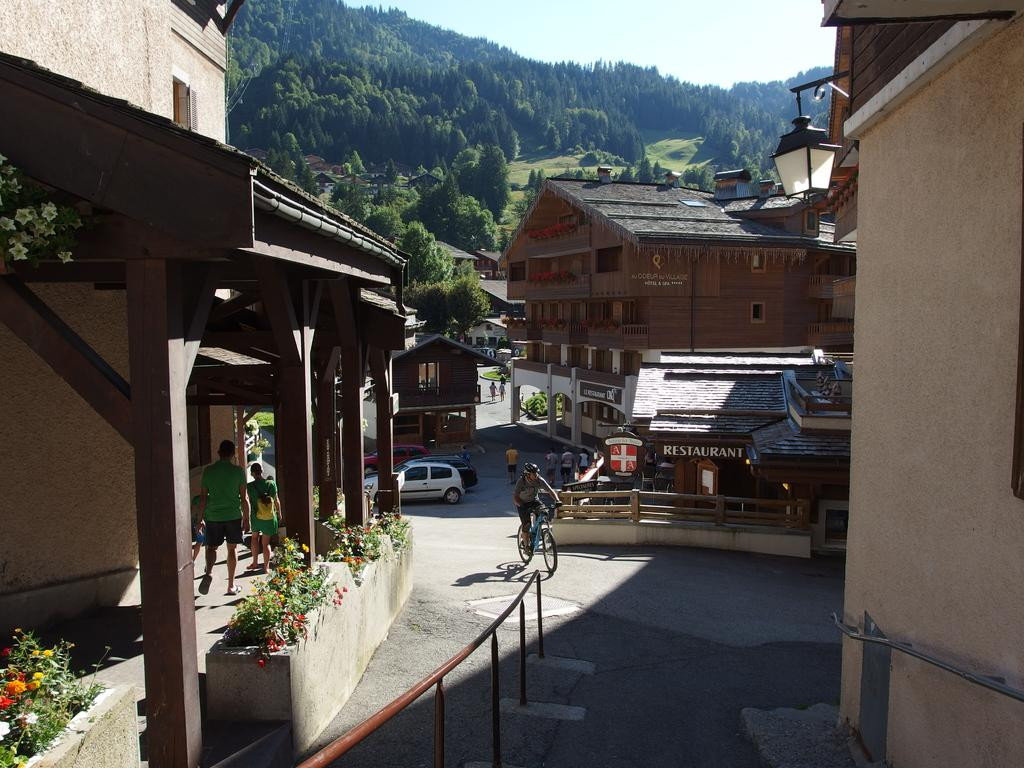<image>
Summarize the visual content of the image. A sign above in a small town has the word restaurant. 